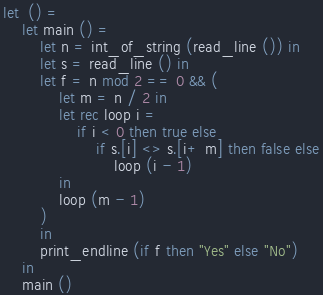<code> <loc_0><loc_0><loc_500><loc_500><_OCaml_>let  () =
    let main () =
        let n = int_of_string (read_line ()) in
        let s = read_line () in
        let f = n mod 2 == 0 && (
            let m = n / 2 in
            let rec loop i =
                if i < 0 then true else
                    if s.[i] <> s.[i+ m] then false else
                        loop (i - 1)
            in
            loop (m - 1)
        )
        in
        print_endline (if f then "Yes" else "No")
    in
    main ()</code> 